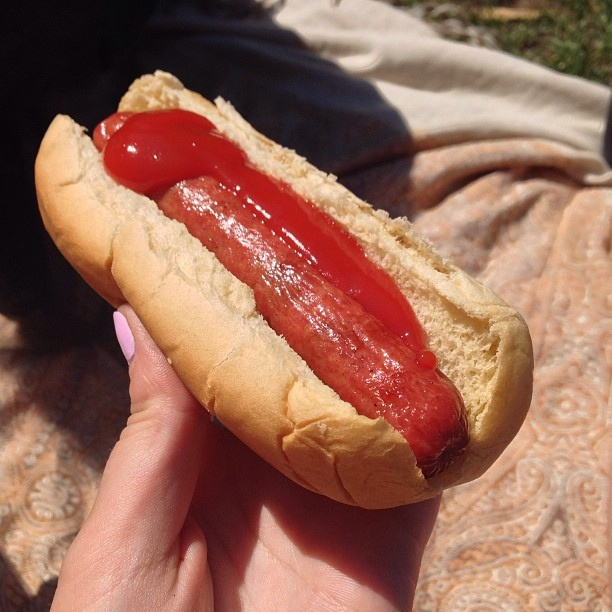Describe the objects in this image and their specific colors. I can see hot dog in black, brown, and tan tones and people in black, maroon, salmon, and brown tones in this image. 